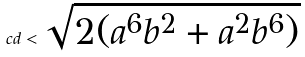Convert formula to latex. <formula><loc_0><loc_0><loc_500><loc_500>c d < \sqrt { 2 ( a ^ { 6 } b ^ { 2 } + a ^ { 2 } b ^ { 6 } ) }</formula> 